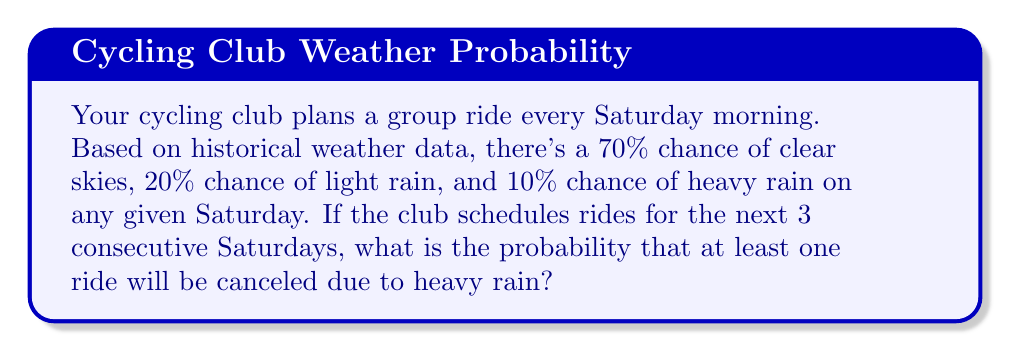Show me your answer to this math problem. Let's approach this step-by-step:

1) First, we need to identify the probability of a ride not being canceled on a single Saturday. This is equal to the probability of either clear skies or light rain:

   $P(\text{ride not canceled}) = 0.70 + 0.20 = 0.90$ or $90\%$

2) The probability of a ride being canceled (due to heavy rain) on a single Saturday is:

   $P(\text{ride canceled}) = 0.10$ or $10\%$

3) For the ride to not be canceled over 3 Saturdays, we need clear skies or light rain on all 3 days. The probability of this is:

   $P(\text{no cancellations in 3 weeks}) = 0.90 \times 0.90 \times 0.90 = 0.90^3 = 0.729$ or $72.9\%$

4) Therefore, the probability of at least one cancellation in 3 weeks is the opposite of no cancellations:

   $P(\text{at least one cancellation}) = 1 - P(\text{no cancellations in 3 weeks})$
   $= 1 - 0.729 = 0.271$ or $27.1\%$

Thus, there is a 27.1% chance that at least one ride will be canceled due to heavy rain over the next 3 Saturdays.
Answer: $27.1\%$ 